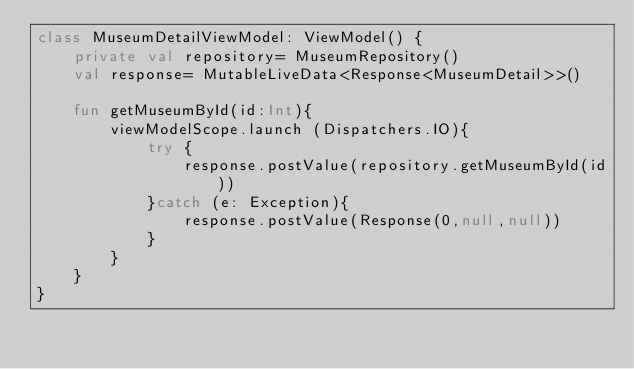Convert code to text. <code><loc_0><loc_0><loc_500><loc_500><_Kotlin_>class MuseumDetailViewModel: ViewModel() {
    private val repository= MuseumRepository()
    val response= MutableLiveData<Response<MuseumDetail>>()

    fun getMuseumById(id:Int){
        viewModelScope.launch (Dispatchers.IO){
            try {
                response.postValue(repository.getMuseumById(id))
            }catch (e: Exception){
                response.postValue(Response(0,null,null))
            }
        }
    }
}</code> 